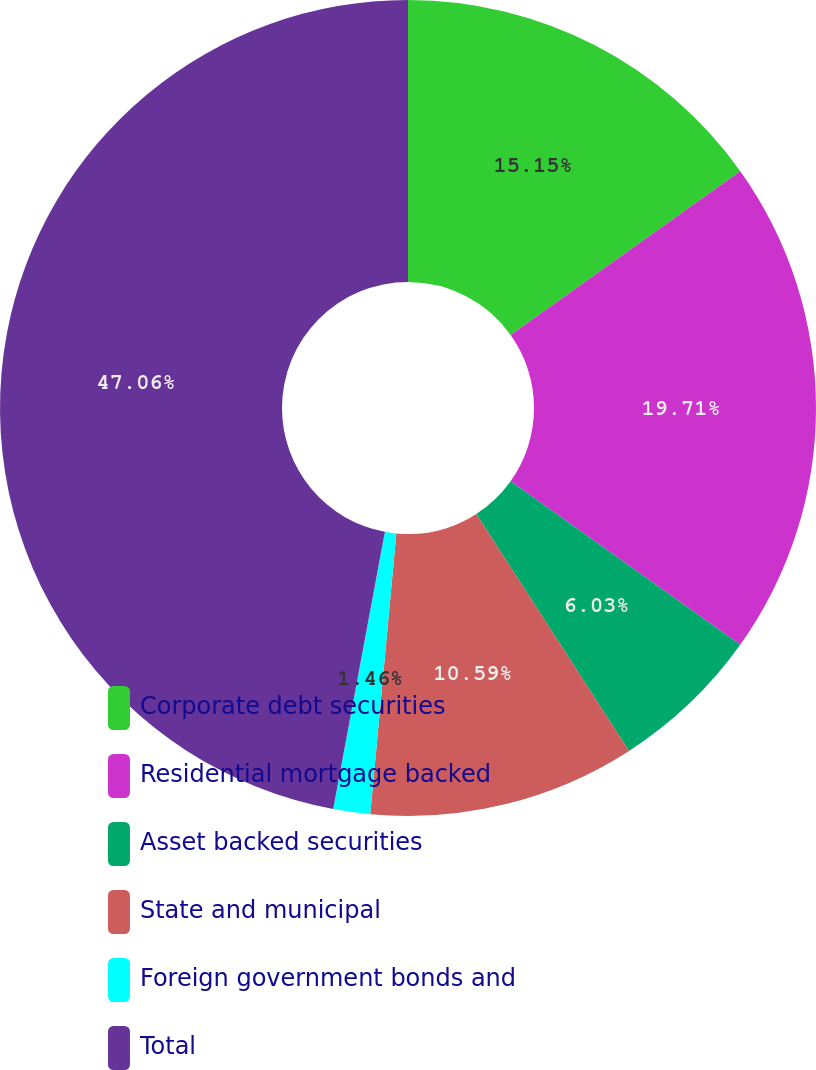<chart> <loc_0><loc_0><loc_500><loc_500><pie_chart><fcel>Corporate debt securities<fcel>Residential mortgage backed<fcel>Asset backed securities<fcel>State and municipal<fcel>Foreign government bonds and<fcel>Total<nl><fcel>15.15%<fcel>19.71%<fcel>6.03%<fcel>10.59%<fcel>1.46%<fcel>47.07%<nl></chart> 